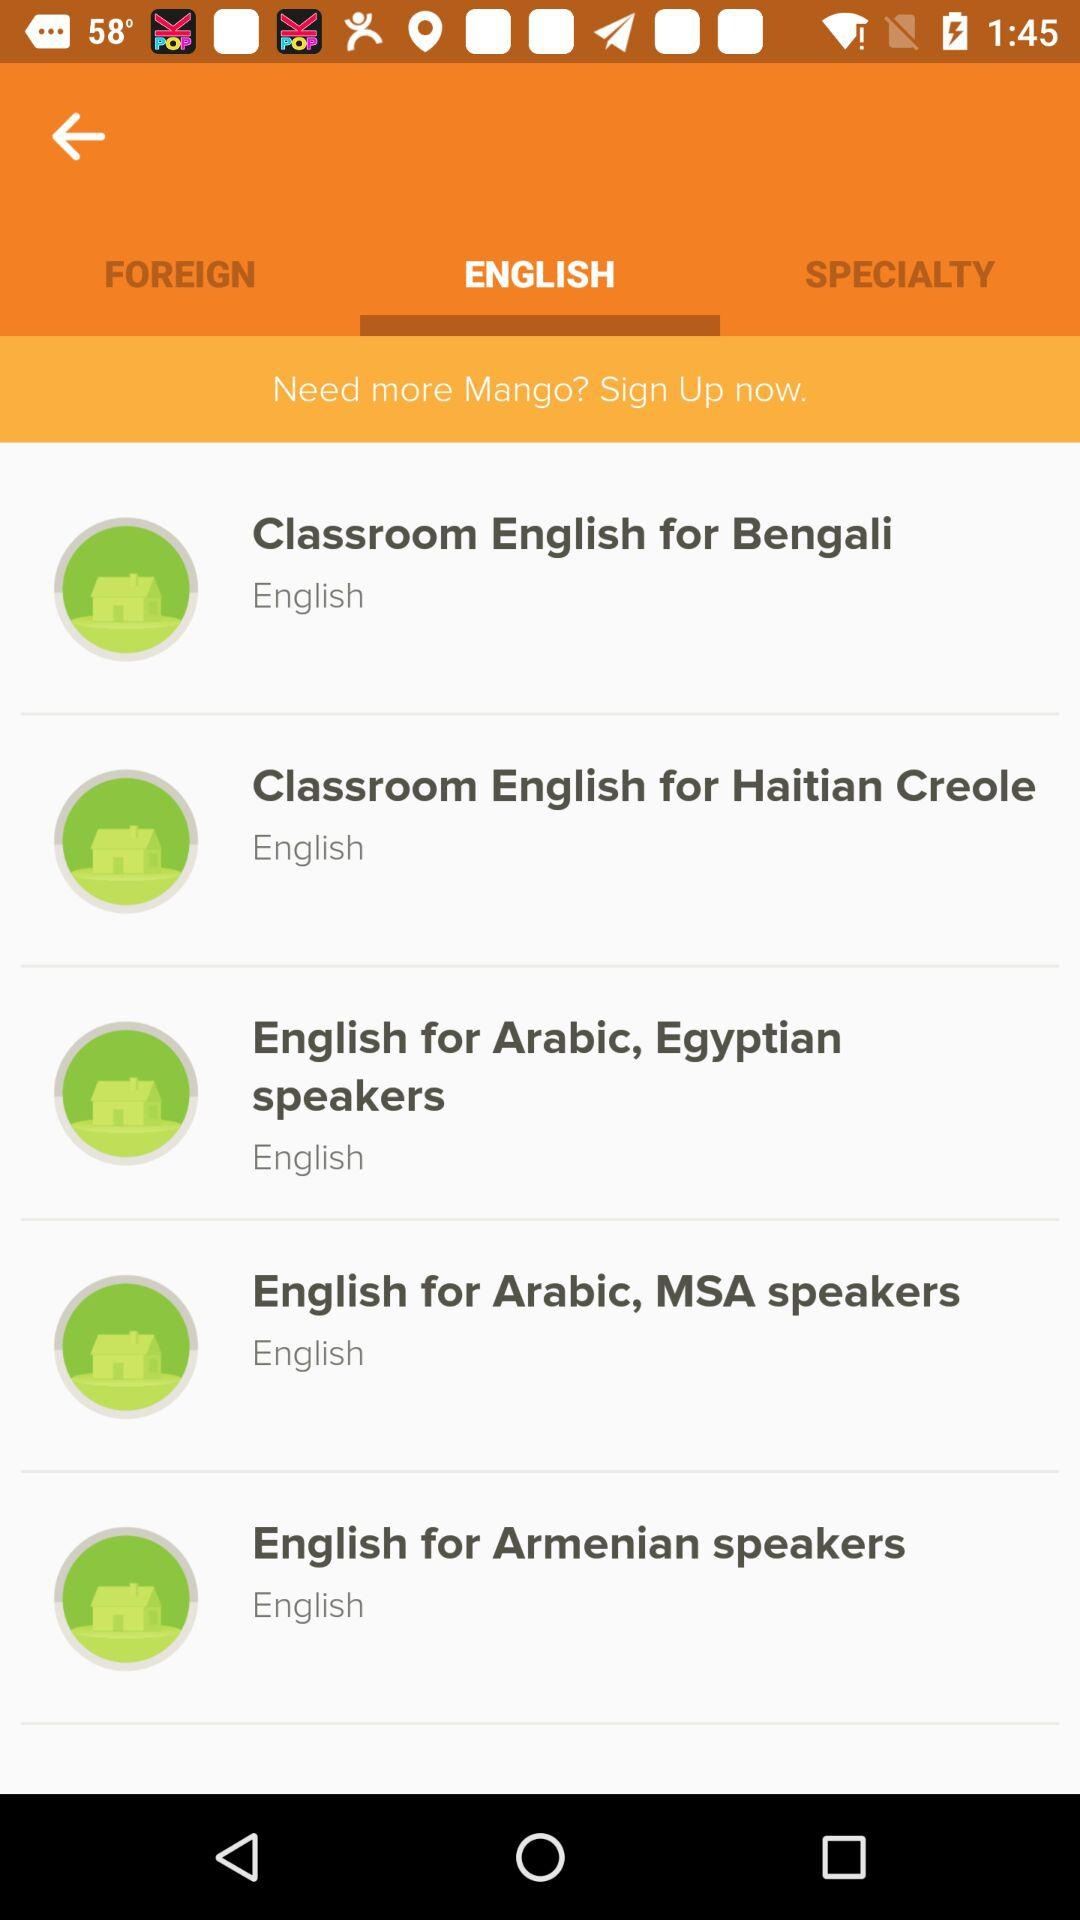How can you gain more Mango? You can gain more Mango by signing up now. 